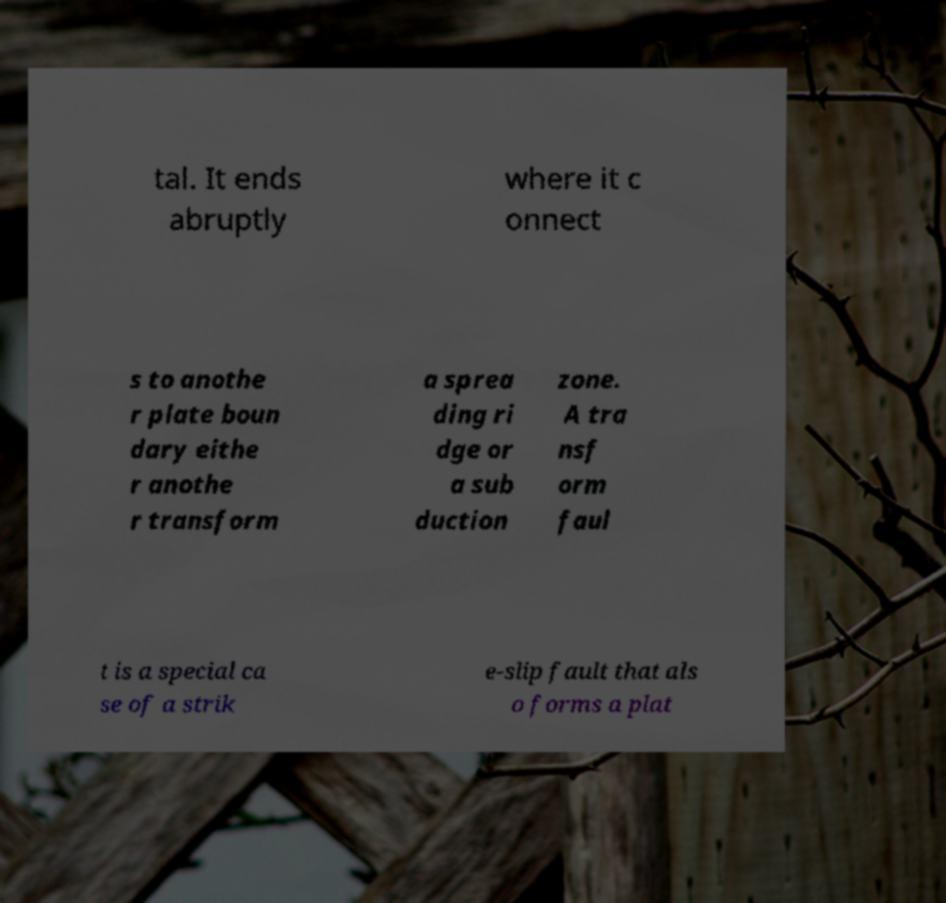Could you assist in decoding the text presented in this image and type it out clearly? tal. It ends abruptly where it c onnect s to anothe r plate boun dary eithe r anothe r transform a sprea ding ri dge or a sub duction zone. A tra nsf orm faul t is a special ca se of a strik e-slip fault that als o forms a plat 